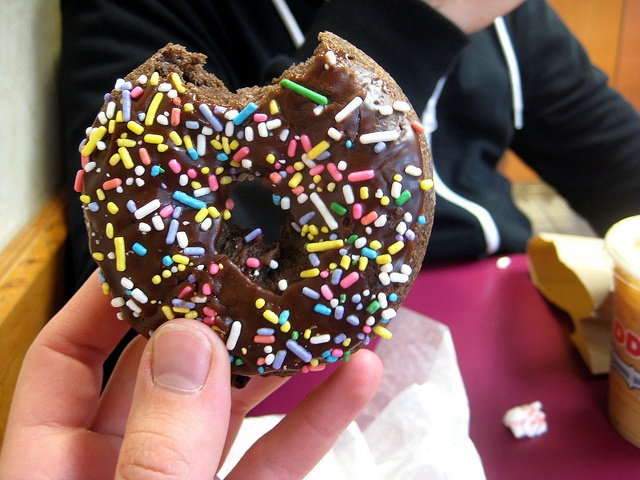Describe the objects in this image and their specific colors. I can see donut in lightgray, black, maroon, white, and gray tones, people in lightgray, black, blue, and gray tones, dining table in lightgray, white, maroon, purple, and brown tones, people in lightgray, lightpink, brown, salmon, and pink tones, and cup in lightgray, maroon, ivory, and brown tones in this image. 